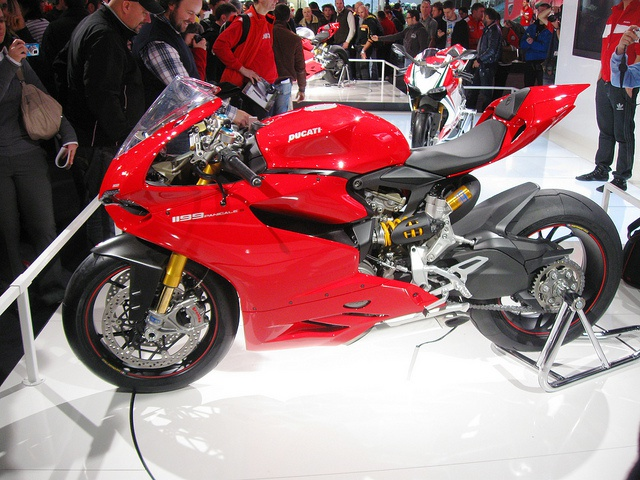Describe the objects in this image and their specific colors. I can see motorcycle in maroon, red, black, gray, and darkgray tones, people in maroon, black, and brown tones, people in maroon, black, gray, and brown tones, people in maroon, black, gray, and brown tones, and motorcycle in maroon, white, black, gray, and darkgray tones in this image. 